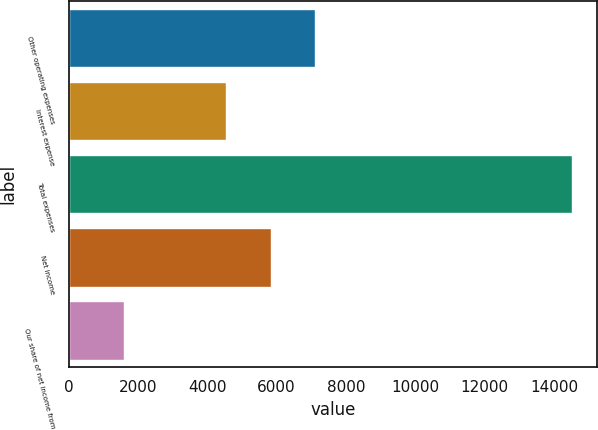Convert chart. <chart><loc_0><loc_0><loc_500><loc_500><bar_chart><fcel>Other operating expenses<fcel>Interest expense<fcel>Total expenses<fcel>Net income<fcel>Our share of net income from<nl><fcel>7117.4<fcel>4537<fcel>14514<fcel>5827.2<fcel>1612<nl></chart> 